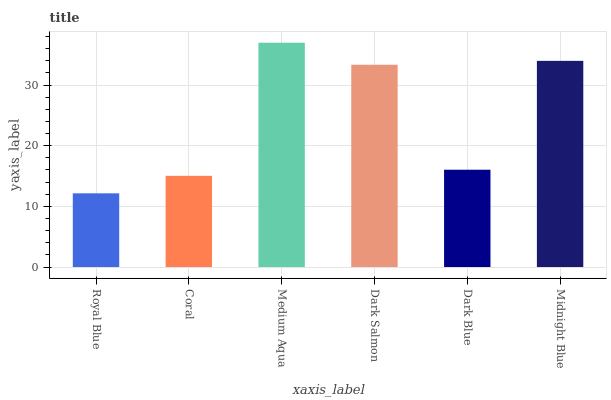Is Royal Blue the minimum?
Answer yes or no. Yes. Is Medium Aqua the maximum?
Answer yes or no. Yes. Is Coral the minimum?
Answer yes or no. No. Is Coral the maximum?
Answer yes or no. No. Is Coral greater than Royal Blue?
Answer yes or no. Yes. Is Royal Blue less than Coral?
Answer yes or no. Yes. Is Royal Blue greater than Coral?
Answer yes or no. No. Is Coral less than Royal Blue?
Answer yes or no. No. Is Dark Salmon the high median?
Answer yes or no. Yes. Is Dark Blue the low median?
Answer yes or no. Yes. Is Coral the high median?
Answer yes or no. No. Is Midnight Blue the low median?
Answer yes or no. No. 